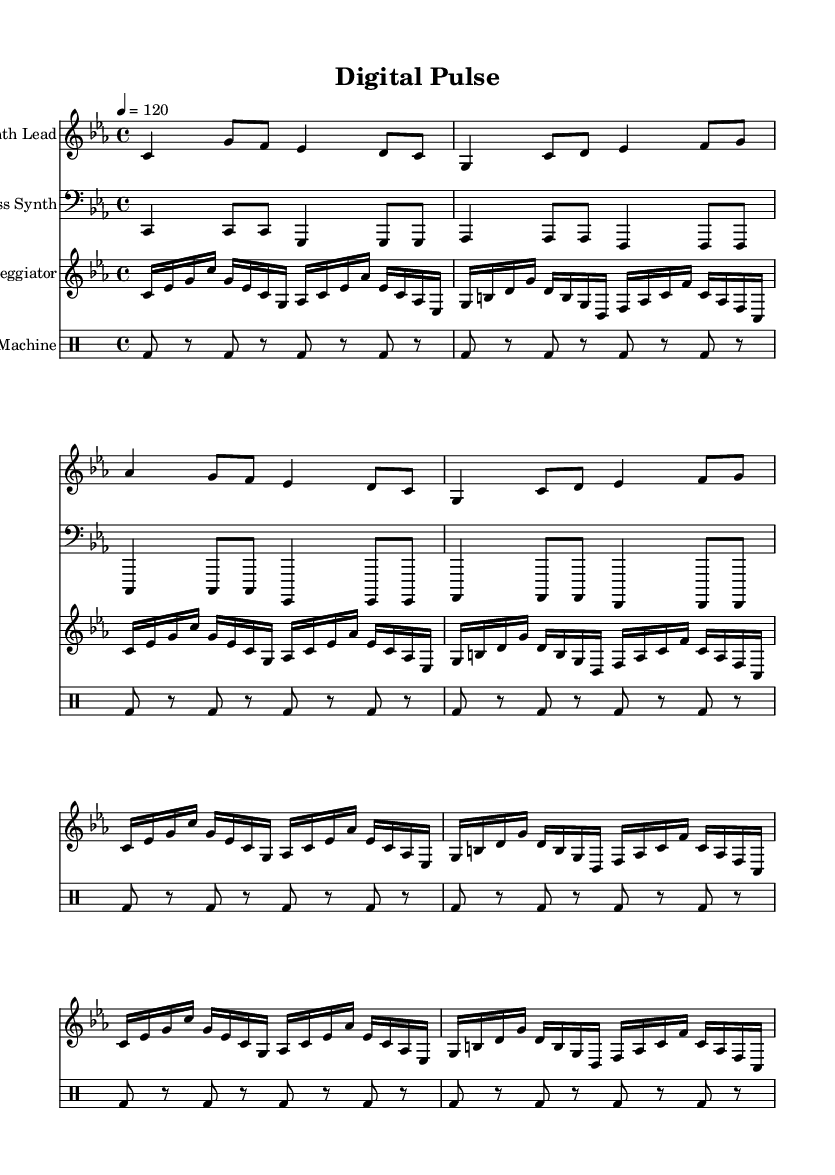What is the key signature of this music? The key signature is C minor, which has three flats (B♭, E♭, A♭). This can be identified in the beginning of the sheet music where the key signature is indicated.
Answer: C minor What is the time signature of this piece? The time signature shown at the beginning of the sheet music is 4/4, meaning there are four beats in each measure and a quarter note gets one beat. This is visible next to the clefs at the start of the score.
Answer: 4/4 What is the tempo marking for this composition? The tempo marking in the score is indicated as quarter note equals 120. This means that the piece is intended to be played at a speed of 120 beats per minute. It is stated at the beginning of the score along with the key signature and time signature.
Answer: 120 How many measures does the synth lead have? To find the number of measures, we count the vertical lines that separate the music into sections. In this case, the synth lead has a total of four measures.
Answer: 4 Which instrument plays the bass line? The instrument designated to play the bass line is labeled as "Bass Synth" in the score. This label is found above the staff where the bass notes are written.
Answer: Bass Synth How many times does the arpeggiator repeat? The arpeggiator section is marked with "\repeat unfold 4", indicating that the pattern within it is repeated four times. This is seen in the specific section of the score where the arpeggiator notes are located.
Answer: 4 times What instrument is indicated for the drum part? The drum part is indicated to be played by a "Drum Machine" as specified in the score. This appears in the title above the drum staff.
Answer: Drum Machine 